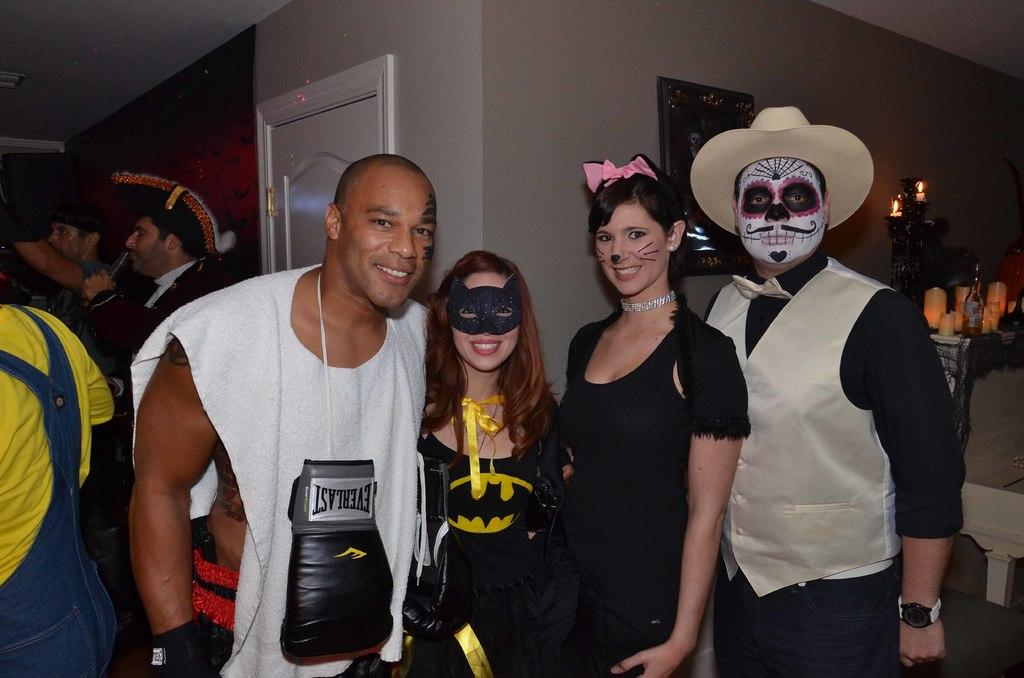<image>
Provide a brief description of the given image. A man poses with others while in a white shirt with an Everlast glove on the front. 